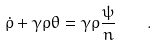Convert formula to latex. <formula><loc_0><loc_0><loc_500><loc_500>\dot { \rho } + \gamma \rho \theta = \gamma \rho \frac { \psi } { n } \quad .</formula> 